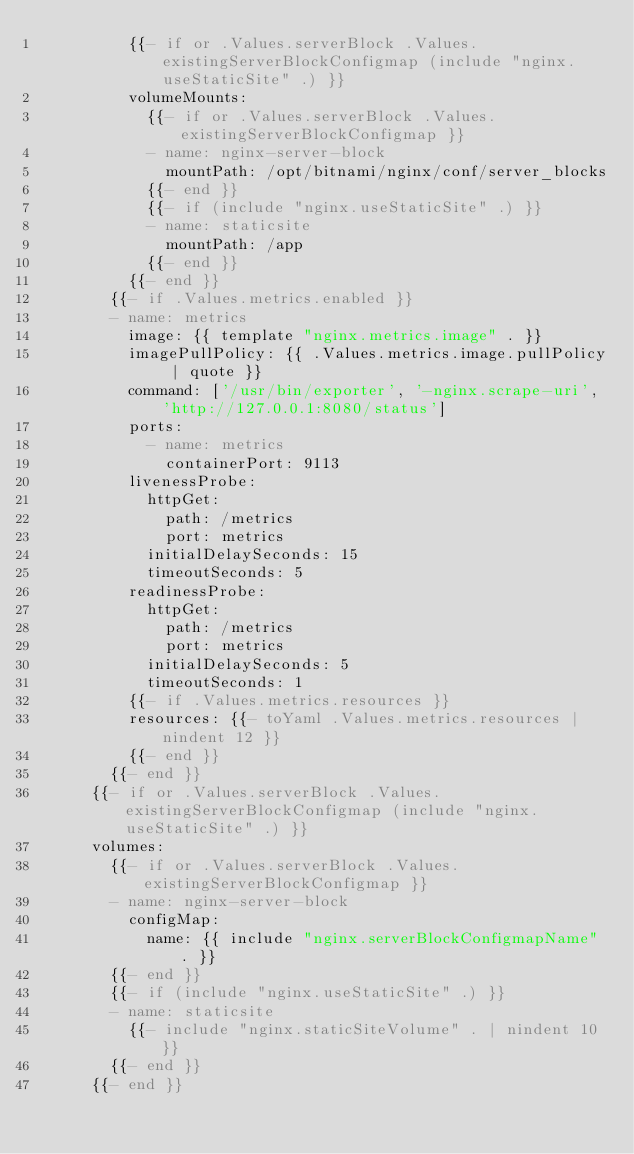Convert code to text. <code><loc_0><loc_0><loc_500><loc_500><_YAML_>          {{- if or .Values.serverBlock .Values.existingServerBlockConfigmap (include "nginx.useStaticSite" .) }}
          volumeMounts:
            {{- if or .Values.serverBlock .Values.existingServerBlockConfigmap }}
            - name: nginx-server-block
              mountPath: /opt/bitnami/nginx/conf/server_blocks
            {{- end }}
            {{- if (include "nginx.useStaticSite" .) }}
            - name: staticsite
              mountPath: /app
            {{- end }}
          {{- end }}
        {{- if .Values.metrics.enabled }}
        - name: metrics
          image: {{ template "nginx.metrics.image" . }}
          imagePullPolicy: {{ .Values.metrics.image.pullPolicy | quote }}
          command: ['/usr/bin/exporter', '-nginx.scrape-uri', 'http://127.0.0.1:8080/status']
          ports:
            - name: metrics
              containerPort: 9113
          livenessProbe:
            httpGet:
              path: /metrics
              port: metrics
            initialDelaySeconds: 15
            timeoutSeconds: 5
          readinessProbe:
            httpGet:
              path: /metrics
              port: metrics
            initialDelaySeconds: 5
            timeoutSeconds: 1
          {{- if .Values.metrics.resources }}
          resources: {{- toYaml .Values.metrics.resources | nindent 12 }}
          {{- end }}
        {{- end }}
      {{- if or .Values.serverBlock .Values.existingServerBlockConfigmap (include "nginx.useStaticSite" .) }}
      volumes:
        {{- if or .Values.serverBlock .Values.existingServerBlockConfigmap }}
        - name: nginx-server-block
          configMap:
            name: {{ include "nginx.serverBlockConfigmapName" . }}
        {{- end }}
        {{- if (include "nginx.useStaticSite" .) }}
        - name: staticsite
          {{- include "nginx.staticSiteVolume" . | nindent 10 }}
        {{- end }}
      {{- end }}
</code> 